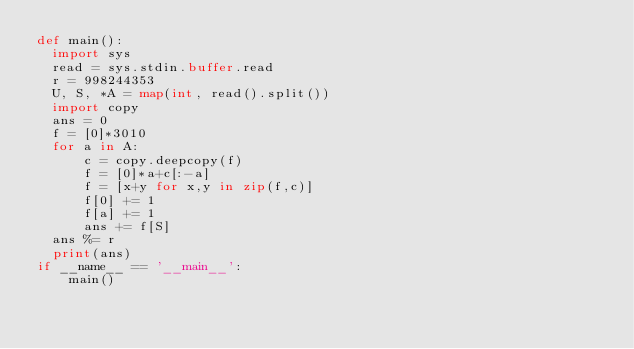<code> <loc_0><loc_0><loc_500><loc_500><_Python_>def main():
  import sys
  read = sys.stdin.buffer.read
  r = 998244353
  U, S, *A = map(int, read().split())
  import copy
  ans = 0
  f = [0]*3010
  for a in A:
      c = copy.deepcopy(f)
      f = [0]*a+c[:-a]
      f = [x+y for x,y in zip(f,c)]
      f[0] += 1
      f[a] += 1
      ans += f[S]
  ans %= r
  print(ans)
if __name__ == '__main__':
    main()</code> 